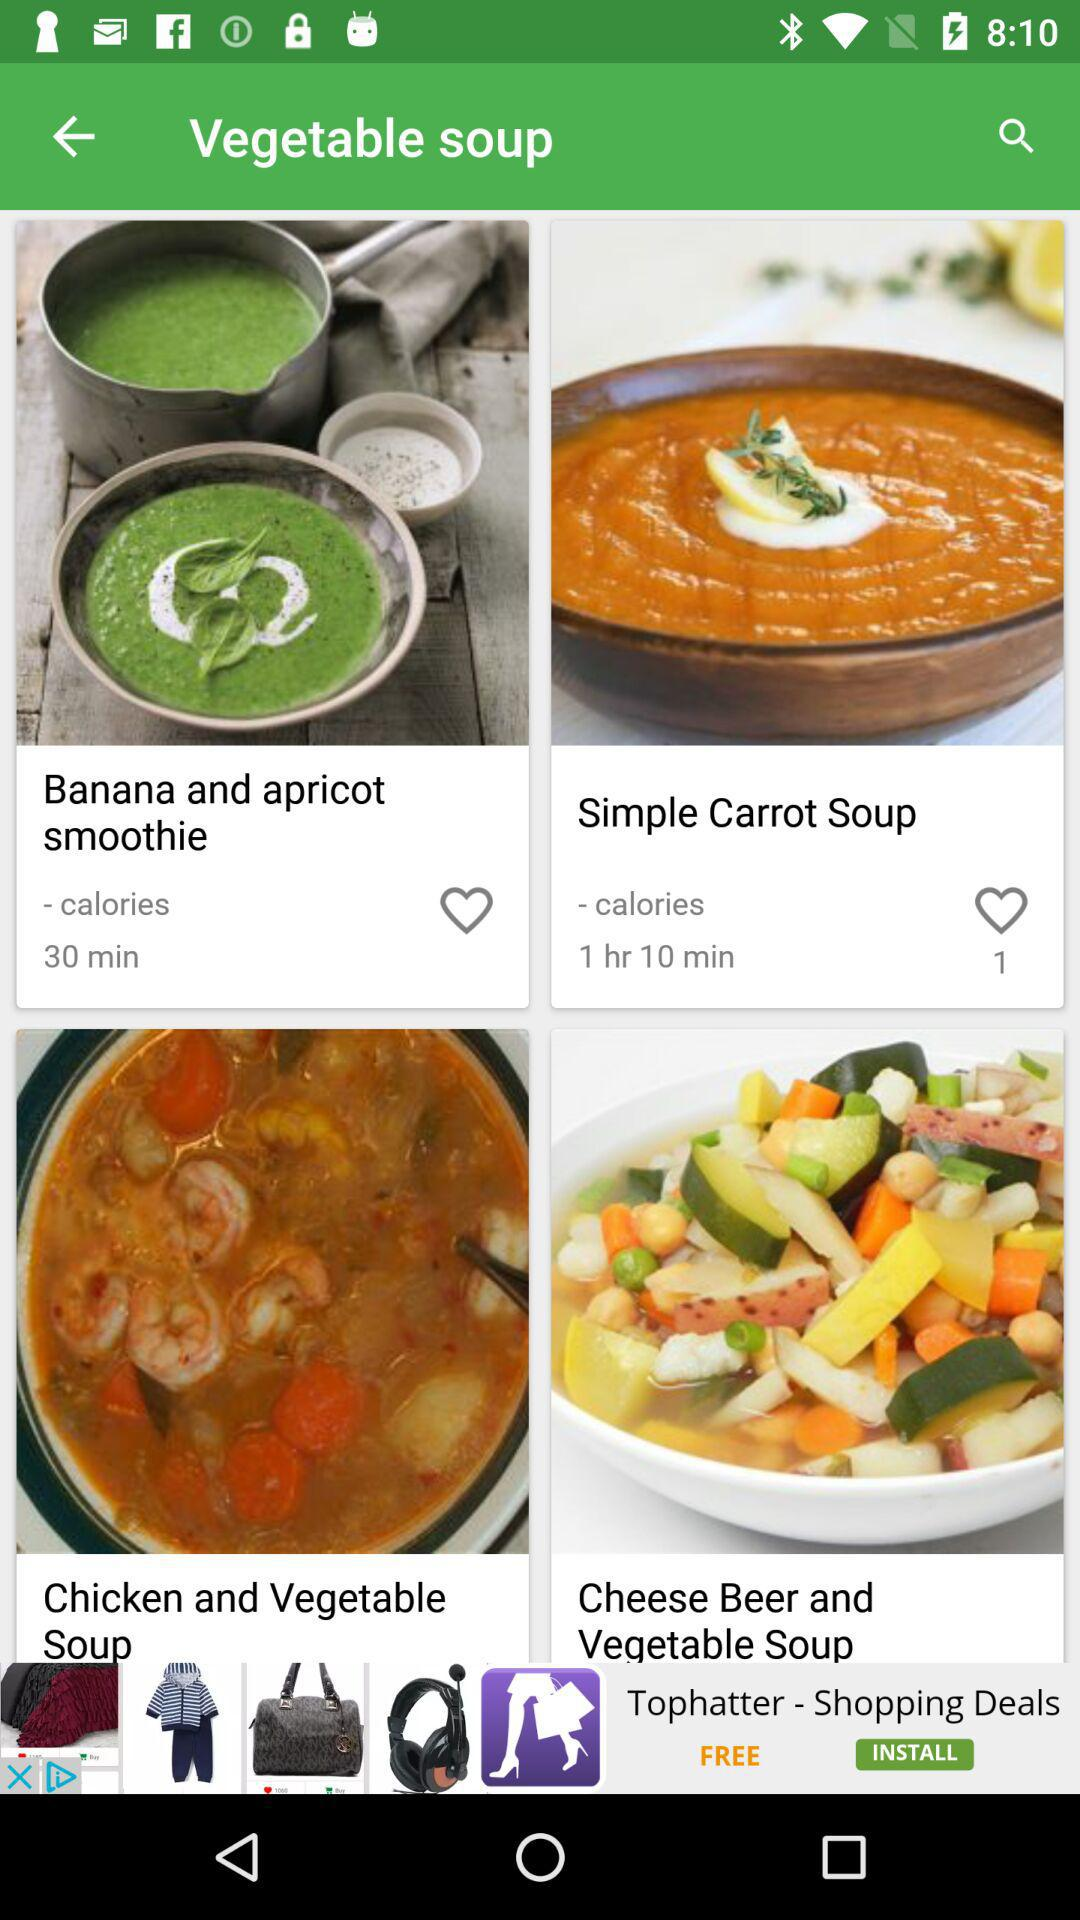How many likes on "Simple Carrot Soup"? There is 1 like. 